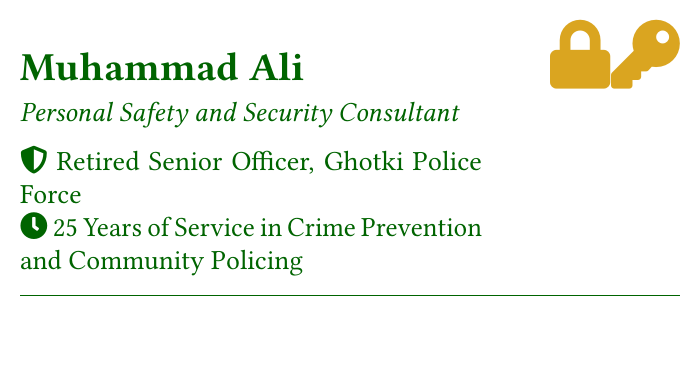What is the consultant's name? The consultant's name is stated at the top of the card, which is Muhammad Ali.
Answer: Muhammad Ali What is the primary service offered? The primary service is indicated under the title and can be found in the subtitle, which is Personal Safety and Security Consultant.
Answer: Personal Safety and Security Consultant How many years of service does the consultant have? The document states that the consultant has 25 years of service in crime prevention and community policing.
Answer: 25 Years What is the phone number provided? The phone number is mentioned in the contact information section of the card.
Answer: +92-300-1234567 What type of assessments does the consultant provide? The document lists "Home Safety Assessments" as one of the services offered by the consultant.
Answer: Home Safety Assessments Where is the consultant's office located? The location is listed in the address part of the contact information.
Answer: 456 Safety Lane, Ghotki, Sindh, Pakistan What symbol is used in the logo? The logo features security symbols, specifically a lock and a key represented by icons.
Answer: lock and key What is the consultant's email address? The email address is provided in the contact section of the card.
Answer: m.ali.securityconsultant@gmail.com What is one of the roles held by the consultant in the police force? The card specifies that the consultant was a Retired Senior Officer in the Ghotki Police Force.
Answer: Retired Senior Officer 